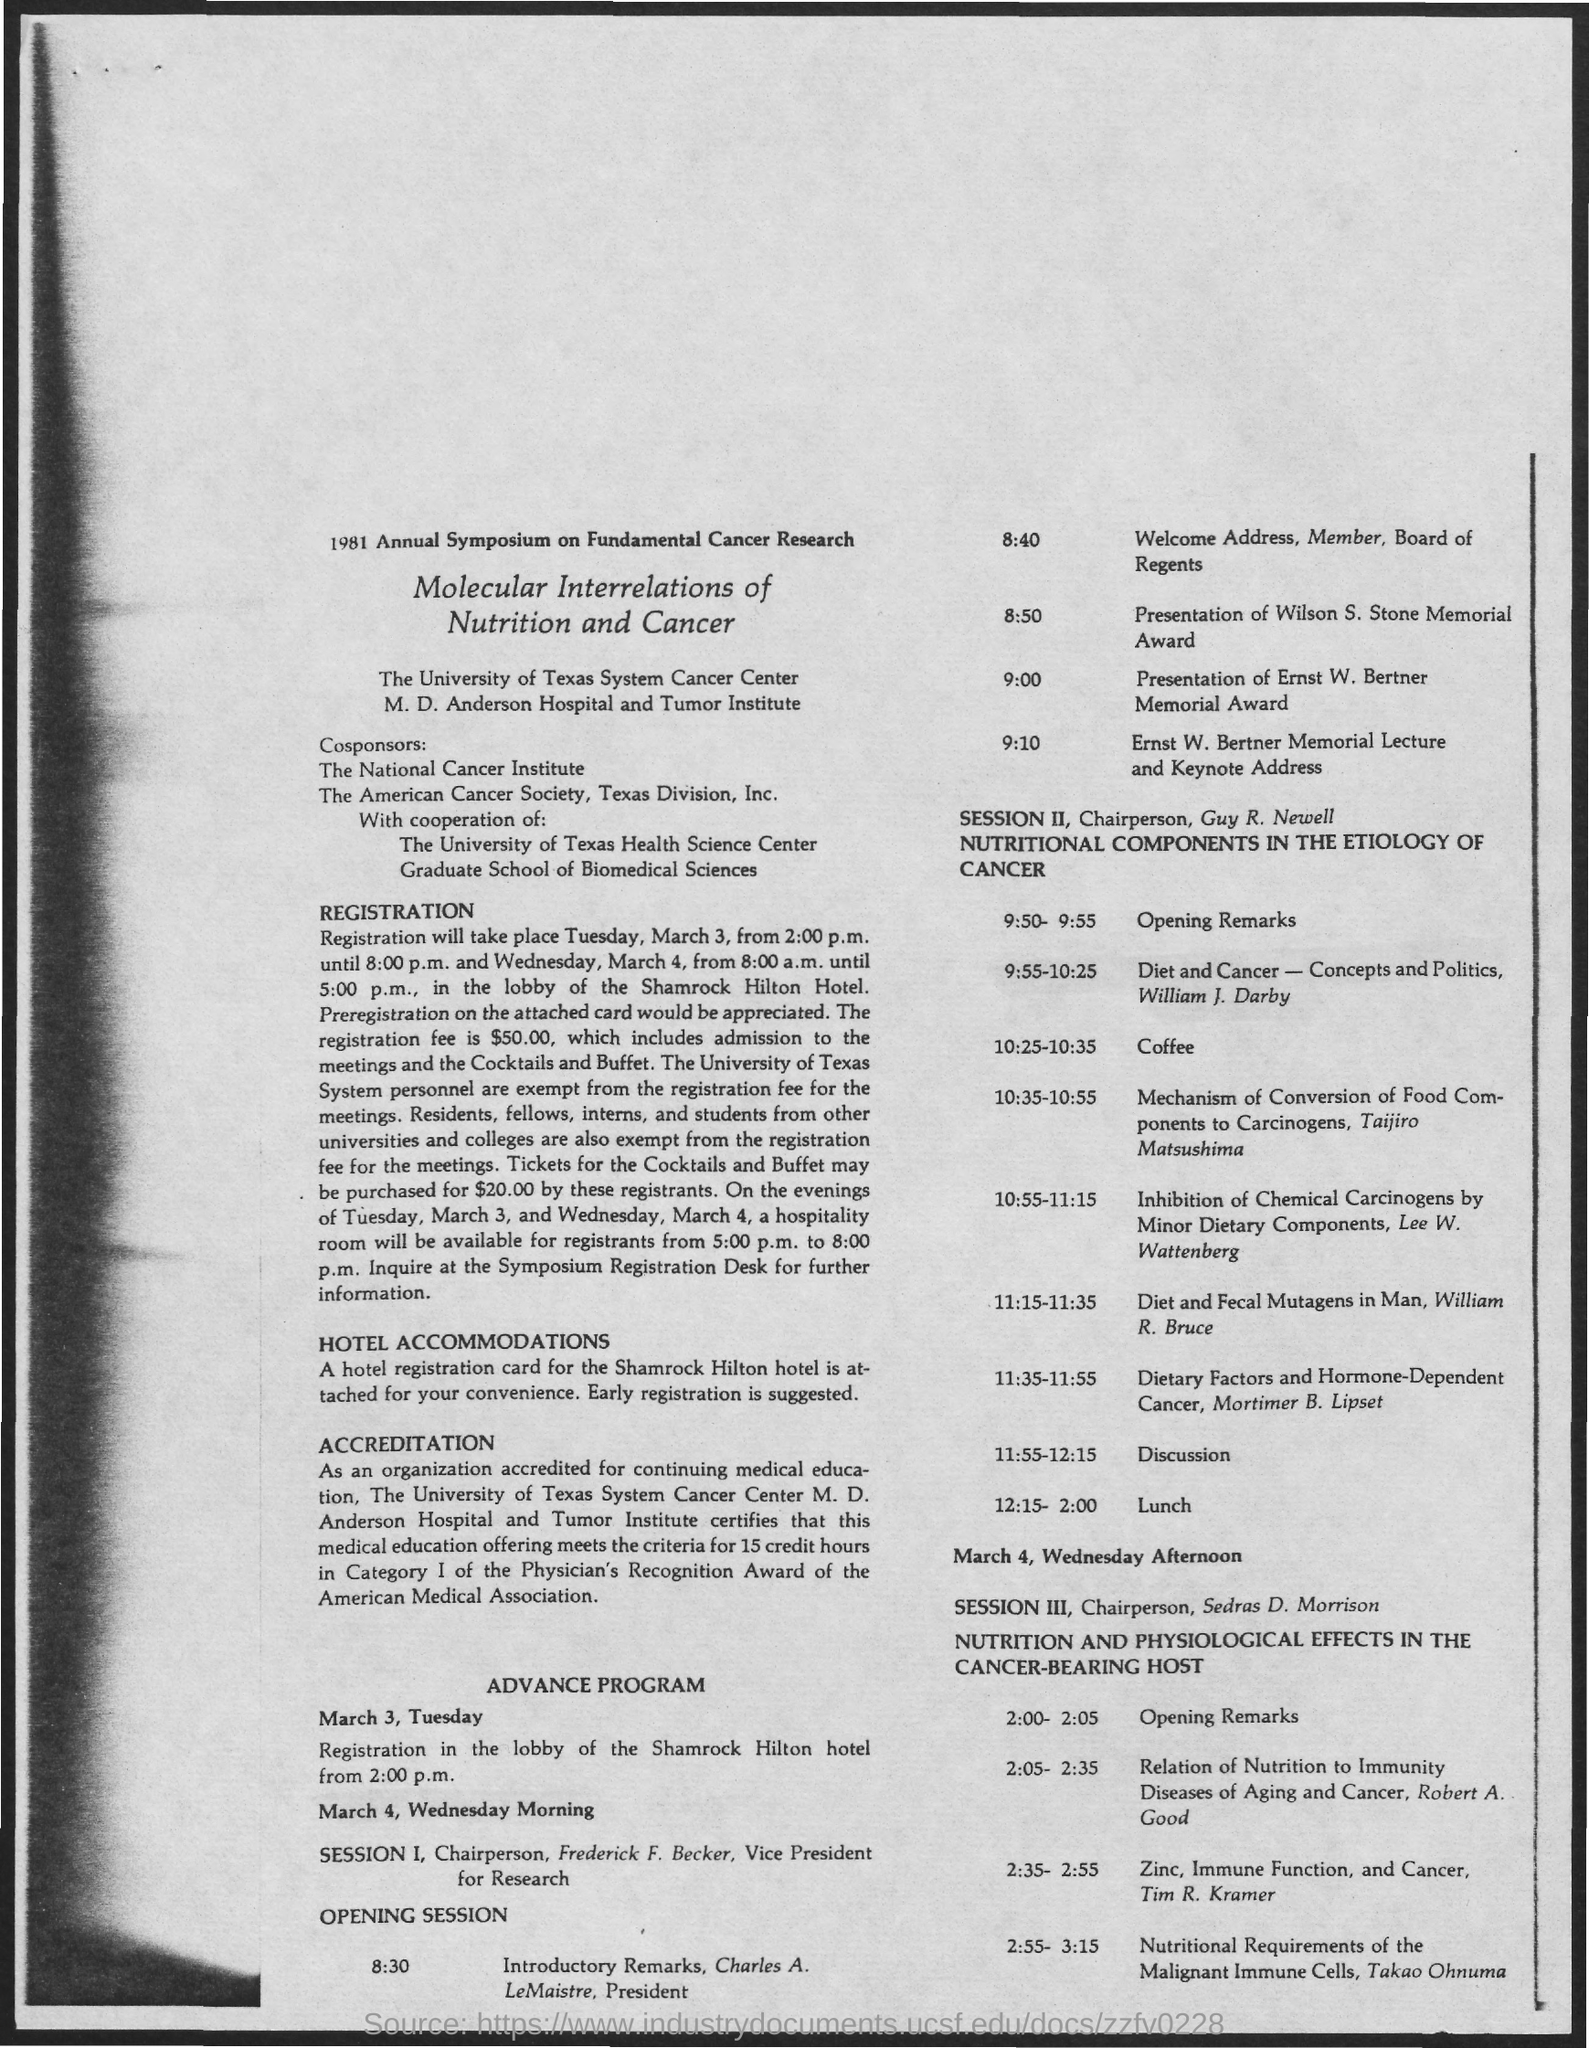What is the schedule mentioned on march 3, tuesday ?
Keep it short and to the point. Registration in the lobby of the Shamrock Hilton hotel from 2:00 p.m. What is the time of opening session mentioned in the given schedule ?
Keep it short and to the point. 8:30. What is the designation of charles a. le maistre ?
Ensure brevity in your answer.  President. What is the schedule at the time of 9:00 ?
Make the answer very short. Presentation of Ernst W. Bertner Memorial Award. What is the schedule at the time of 12:15 - 2:00 in session 2 ?
Your answer should be very brief. Lunch. What is the schedule at the time of 10:25 - 10:35 ?
Your answer should be compact. Coffee. Who is the chairperson for session ii as mentioned in the given page ?
Offer a terse response. Guy R. Newell. Who is the chairperson for session iii as mentioned in the given page ?
Provide a succinct answer. Sedras d. morrison. What is the schedule given at the time of 11:55 - 12:15 in session ii ?
Your response must be concise. Discussion. 